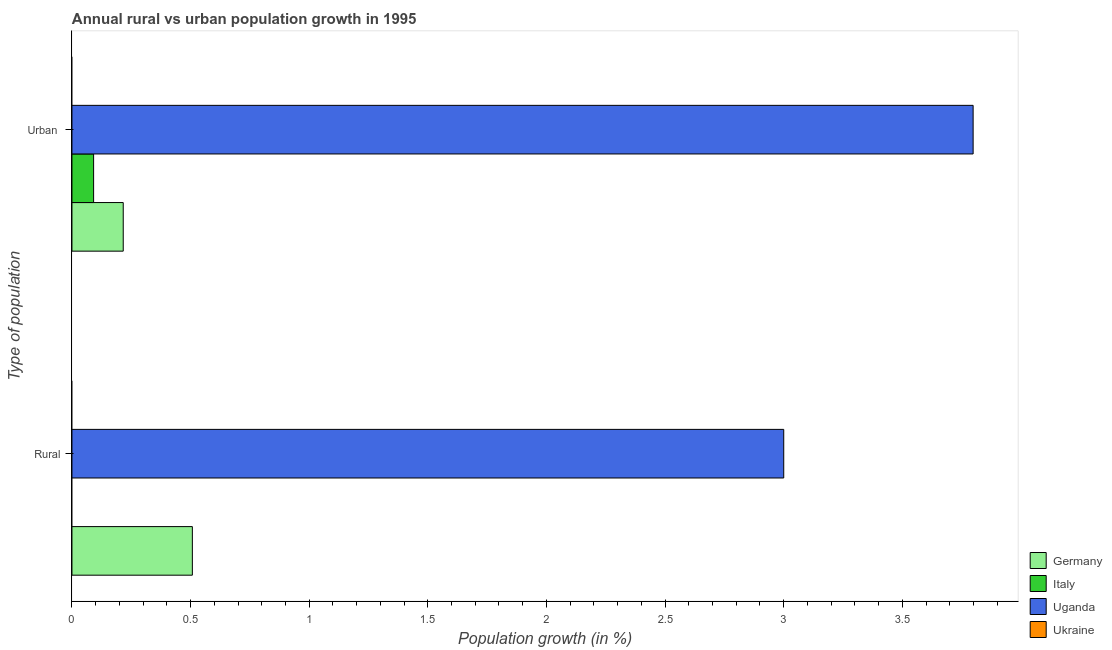How many groups of bars are there?
Give a very brief answer. 2. Are the number of bars per tick equal to the number of legend labels?
Ensure brevity in your answer.  No. Are the number of bars on each tick of the Y-axis equal?
Ensure brevity in your answer.  No. What is the label of the 1st group of bars from the top?
Offer a terse response. Urban . What is the rural population growth in Germany?
Offer a terse response. 0.51. Across all countries, what is the maximum rural population growth?
Provide a succinct answer. 3. In which country was the rural population growth maximum?
Your answer should be very brief. Uganda. What is the total urban population growth in the graph?
Offer a very short reply. 4.11. What is the difference between the urban population growth in Germany and that in Italy?
Make the answer very short. 0.12. What is the difference between the urban population growth in Uganda and the rural population growth in Italy?
Keep it short and to the point. 3.8. What is the average rural population growth per country?
Your answer should be very brief. 0.88. What is the difference between the rural population growth and urban population growth in Uganda?
Offer a terse response. -0.8. In how many countries, is the urban population growth greater than 2.8 %?
Your answer should be very brief. 1. What is the ratio of the urban population growth in Germany to that in Italy?
Provide a short and direct response. 2.37. In how many countries, is the urban population growth greater than the average urban population growth taken over all countries?
Your answer should be very brief. 1. How many bars are there?
Make the answer very short. 5. How many countries are there in the graph?
Provide a short and direct response. 4. What is the difference between two consecutive major ticks on the X-axis?
Provide a succinct answer. 0.5. Does the graph contain grids?
Give a very brief answer. No. What is the title of the graph?
Provide a succinct answer. Annual rural vs urban population growth in 1995. Does "China" appear as one of the legend labels in the graph?
Offer a very short reply. No. What is the label or title of the X-axis?
Provide a succinct answer. Population growth (in %). What is the label or title of the Y-axis?
Give a very brief answer. Type of population. What is the Population growth (in %) of Germany in Rural?
Your answer should be compact. 0.51. What is the Population growth (in %) of Uganda in Rural?
Give a very brief answer. 3. What is the Population growth (in %) in Germany in Urban ?
Provide a short and direct response. 0.22. What is the Population growth (in %) of Italy in Urban ?
Ensure brevity in your answer.  0.09. What is the Population growth (in %) of Uganda in Urban ?
Your answer should be compact. 3.8. What is the Population growth (in %) of Ukraine in Urban ?
Provide a short and direct response. 0. Across all Type of population, what is the maximum Population growth (in %) in Germany?
Provide a succinct answer. 0.51. Across all Type of population, what is the maximum Population growth (in %) of Italy?
Give a very brief answer. 0.09. Across all Type of population, what is the maximum Population growth (in %) in Uganda?
Offer a very short reply. 3.8. Across all Type of population, what is the minimum Population growth (in %) of Germany?
Offer a terse response. 0.22. Across all Type of population, what is the minimum Population growth (in %) in Italy?
Your response must be concise. 0. Across all Type of population, what is the minimum Population growth (in %) of Uganda?
Offer a terse response. 3. What is the total Population growth (in %) in Germany in the graph?
Provide a short and direct response. 0.72. What is the total Population growth (in %) of Italy in the graph?
Provide a short and direct response. 0.09. What is the total Population growth (in %) of Uganda in the graph?
Provide a short and direct response. 6.8. What is the difference between the Population growth (in %) in Germany in Rural and that in Urban ?
Your answer should be compact. 0.29. What is the difference between the Population growth (in %) in Uganda in Rural and that in Urban ?
Provide a short and direct response. -0.8. What is the difference between the Population growth (in %) in Germany in Rural and the Population growth (in %) in Italy in Urban ?
Offer a terse response. 0.42. What is the difference between the Population growth (in %) of Germany in Rural and the Population growth (in %) of Uganda in Urban ?
Give a very brief answer. -3.29. What is the average Population growth (in %) in Germany per Type of population?
Provide a short and direct response. 0.36. What is the average Population growth (in %) in Italy per Type of population?
Give a very brief answer. 0.05. What is the average Population growth (in %) in Uganda per Type of population?
Your answer should be compact. 3.4. What is the difference between the Population growth (in %) of Germany and Population growth (in %) of Uganda in Rural?
Ensure brevity in your answer.  -2.49. What is the difference between the Population growth (in %) in Germany and Population growth (in %) in Italy in Urban ?
Make the answer very short. 0.12. What is the difference between the Population growth (in %) in Germany and Population growth (in %) in Uganda in Urban ?
Provide a short and direct response. -3.58. What is the difference between the Population growth (in %) of Italy and Population growth (in %) of Uganda in Urban ?
Provide a succinct answer. -3.71. What is the ratio of the Population growth (in %) in Germany in Rural to that in Urban ?
Provide a succinct answer. 2.35. What is the ratio of the Population growth (in %) in Uganda in Rural to that in Urban ?
Your response must be concise. 0.79. What is the difference between the highest and the second highest Population growth (in %) in Germany?
Offer a very short reply. 0.29. What is the difference between the highest and the second highest Population growth (in %) in Uganda?
Offer a very short reply. 0.8. What is the difference between the highest and the lowest Population growth (in %) of Germany?
Provide a short and direct response. 0.29. What is the difference between the highest and the lowest Population growth (in %) in Italy?
Provide a succinct answer. 0.09. What is the difference between the highest and the lowest Population growth (in %) in Uganda?
Keep it short and to the point. 0.8. 